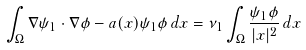<formula> <loc_0><loc_0><loc_500><loc_500>\int _ { \Omega } \nabla \psi _ { 1 } \cdot \nabla \phi - a ( x ) \psi _ { 1 } \phi \, d x = \nu _ { 1 } \int _ { \Omega } \frac { \psi _ { 1 } \phi } { | x | ^ { 2 } } \, d x</formula> 